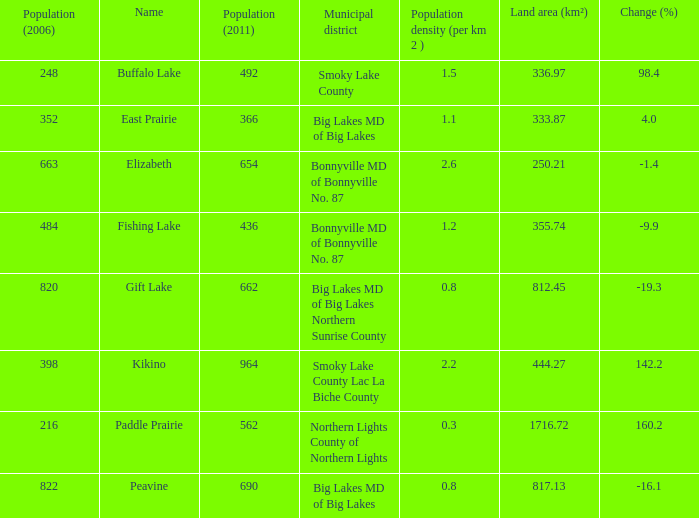What is the density per km in Smoky Lake County? 1.5. 